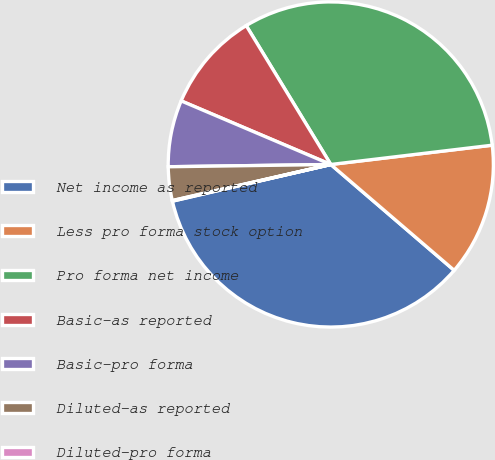Convert chart. <chart><loc_0><loc_0><loc_500><loc_500><pie_chart><fcel>Net income as reported<fcel>Less pro forma stock option<fcel>Pro forma net income<fcel>Basic-as reported<fcel>Basic-pro forma<fcel>Diluted-as reported<fcel>Diluted-pro forma<nl><fcel>35.1%<fcel>13.18%<fcel>31.82%<fcel>9.9%<fcel>6.62%<fcel>3.34%<fcel>0.06%<nl></chart> 